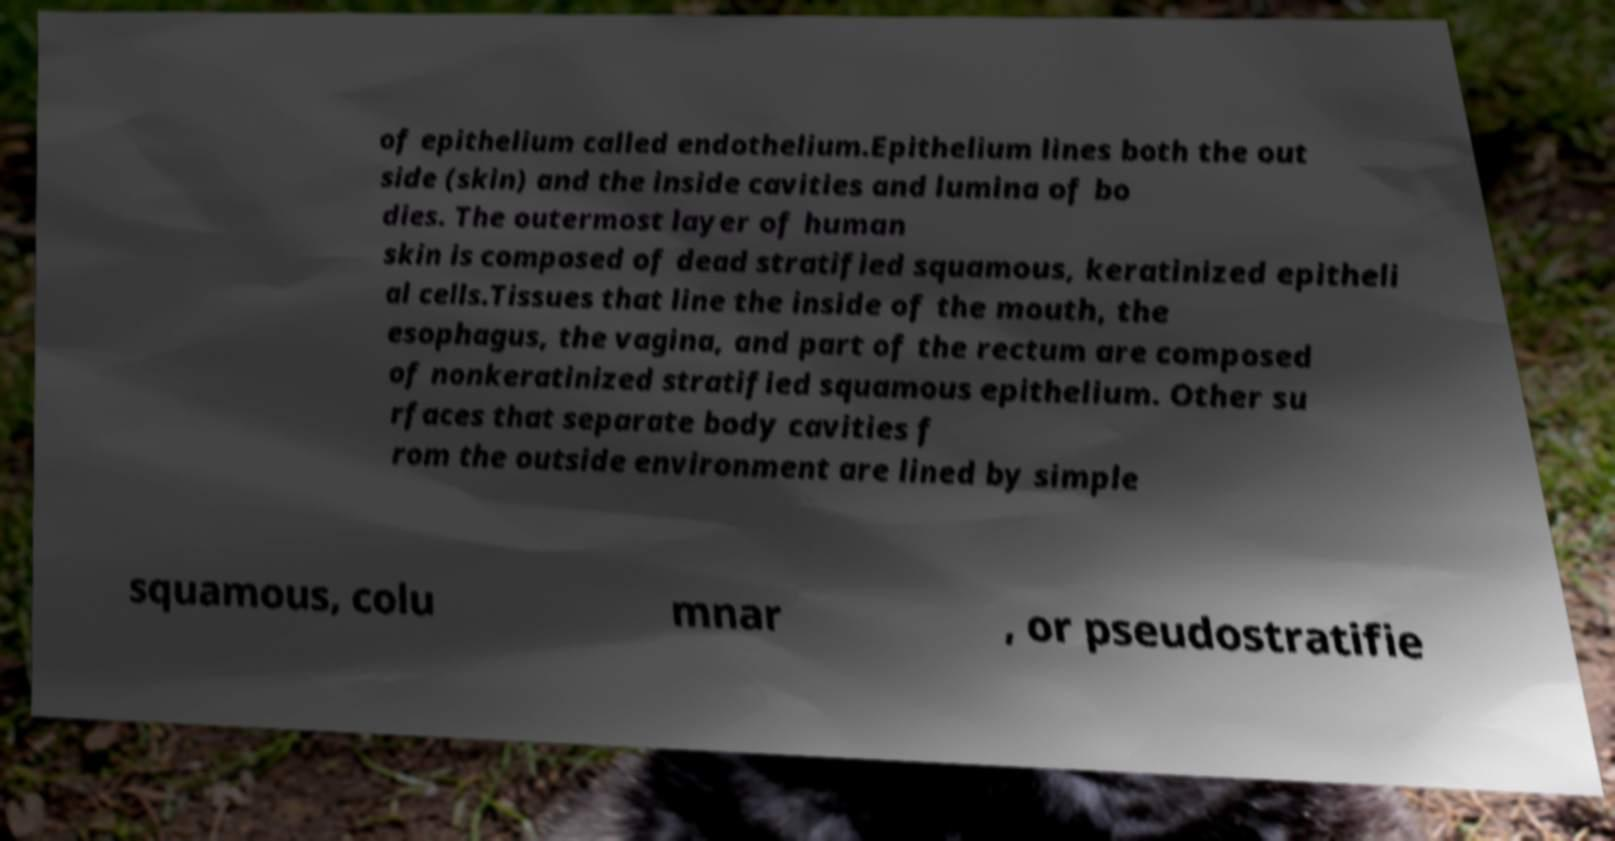Could you assist in decoding the text presented in this image and type it out clearly? of epithelium called endothelium.Epithelium lines both the out side (skin) and the inside cavities and lumina of bo dies. The outermost layer of human skin is composed of dead stratified squamous, keratinized epitheli al cells.Tissues that line the inside of the mouth, the esophagus, the vagina, and part of the rectum are composed of nonkeratinized stratified squamous epithelium. Other su rfaces that separate body cavities f rom the outside environment are lined by simple squamous, colu mnar , or pseudostratifie 